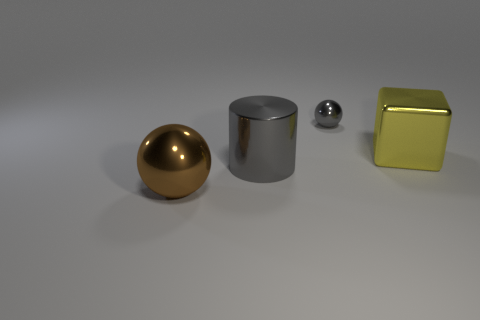Add 2 big metallic balls. How many objects exist? 6 Subtract all brown balls. How many balls are left? 1 Subtract all blocks. How many objects are left? 3 Add 4 big shiny things. How many big shiny things exist? 7 Subtract 1 gray cylinders. How many objects are left? 3 Subtract all gray metallic balls. Subtract all big cubes. How many objects are left? 2 Add 2 gray balls. How many gray balls are left? 3 